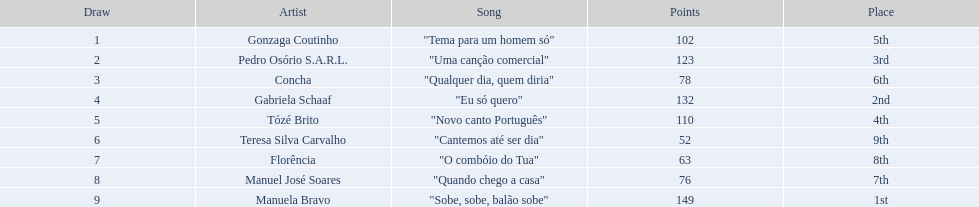Which song ranked second in the competition? "Eu só quero". Who performed eu so quero? Gabriela Schaaf. 